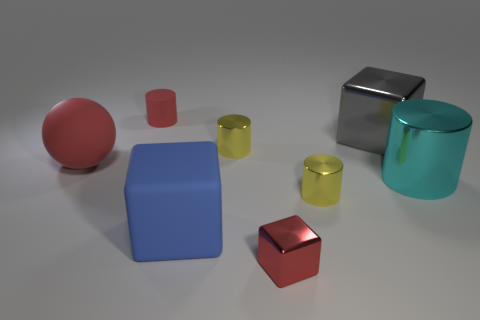Subtract 1 cylinders. How many cylinders are left? 3 Add 1 large yellow metal objects. How many objects exist? 9 Subtract all blocks. How many objects are left? 5 Add 7 yellow cylinders. How many yellow cylinders exist? 9 Subtract 1 red cylinders. How many objects are left? 7 Subtract all tiny metallic cylinders. Subtract all small red metallic objects. How many objects are left? 5 Add 5 gray cubes. How many gray cubes are left? 6 